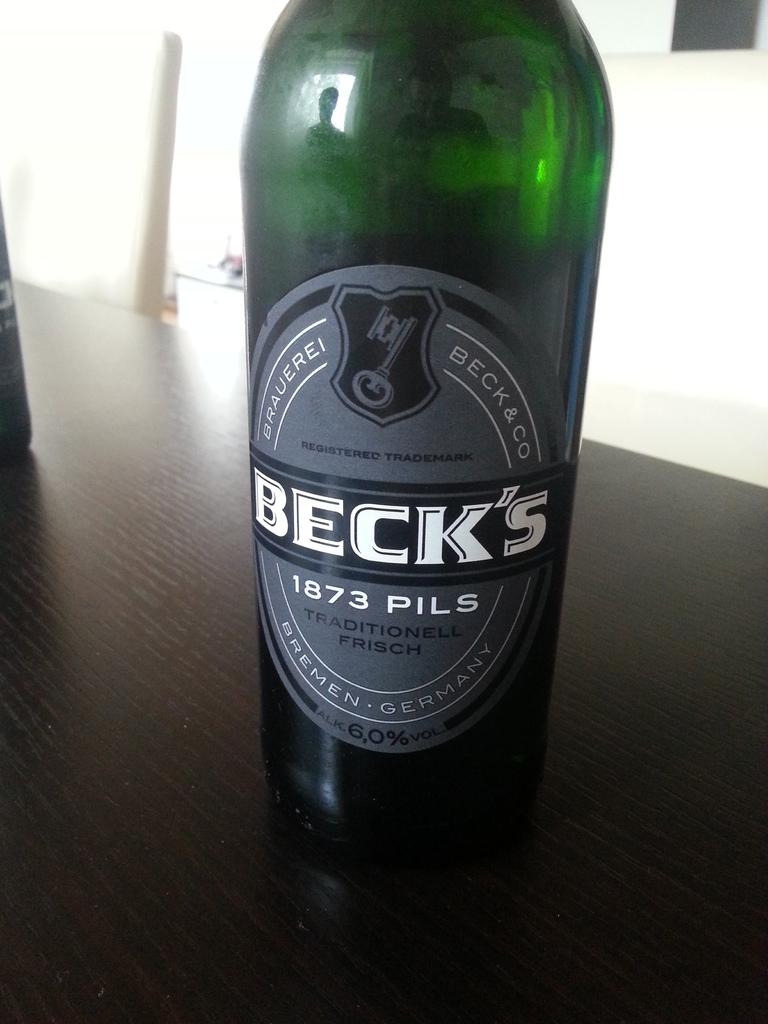<image>
Describe the image concisely. A green bottle of a Beck's beverage which mentions Germany. 